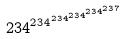Convert formula to latex. <formula><loc_0><loc_0><loc_500><loc_500>2 3 4 ^ { 2 3 4 ^ { 2 3 4 ^ { 2 3 4 ^ { 2 3 4 ^ { 2 3 7 } } } } }</formula> 